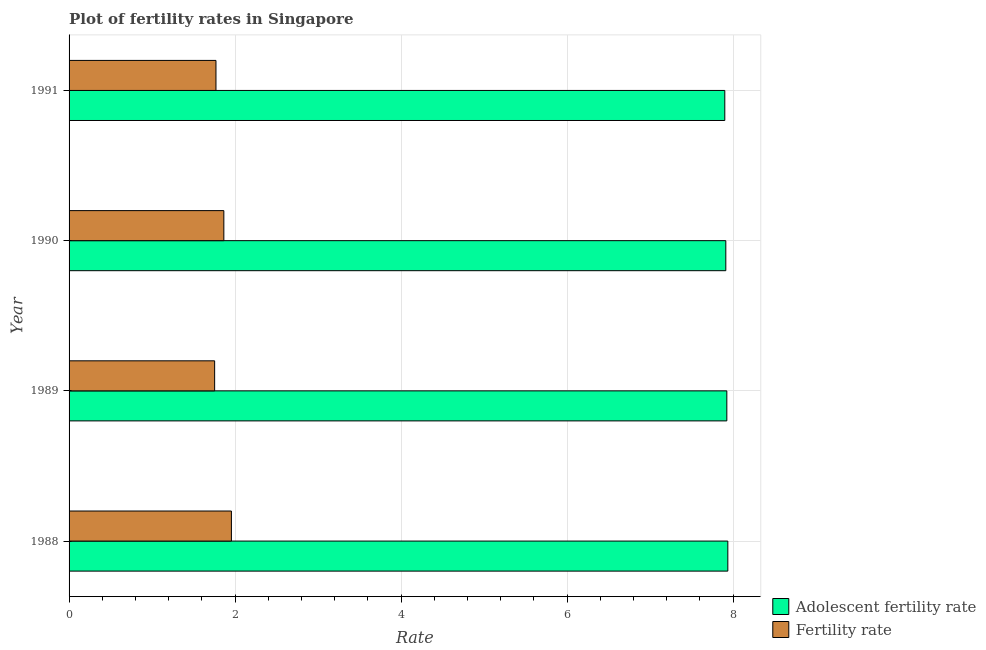Are the number of bars per tick equal to the number of legend labels?
Your answer should be very brief. Yes. Are the number of bars on each tick of the Y-axis equal?
Your response must be concise. Yes. What is the fertility rate in 1991?
Your response must be concise. 1.77. Across all years, what is the maximum adolescent fertility rate?
Make the answer very short. 7.94. Across all years, what is the minimum fertility rate?
Your answer should be compact. 1.75. In which year was the adolescent fertility rate minimum?
Your answer should be very brief. 1991. What is the total fertility rate in the graph?
Provide a short and direct response. 7.35. What is the difference between the adolescent fertility rate in 1989 and that in 1990?
Provide a succinct answer. 0.01. What is the difference between the fertility rate in 1990 and the adolescent fertility rate in 1991?
Offer a very short reply. -6.04. What is the average adolescent fertility rate per year?
Keep it short and to the point. 7.92. In the year 1989, what is the difference between the fertility rate and adolescent fertility rate?
Offer a terse response. -6.17. What is the ratio of the fertility rate in 1990 to that in 1991?
Keep it short and to the point. 1.05. Is the adolescent fertility rate in 1989 less than that in 1991?
Your response must be concise. No. What is the difference between the highest and the second highest adolescent fertility rate?
Provide a short and direct response. 0.01. What does the 2nd bar from the top in 1988 represents?
Provide a short and direct response. Adolescent fertility rate. What does the 1st bar from the bottom in 1991 represents?
Offer a terse response. Adolescent fertility rate. How many bars are there?
Make the answer very short. 8. Are all the bars in the graph horizontal?
Provide a short and direct response. Yes. Are the values on the major ticks of X-axis written in scientific E-notation?
Your response must be concise. No. Where does the legend appear in the graph?
Offer a terse response. Bottom right. How many legend labels are there?
Provide a succinct answer. 2. What is the title of the graph?
Ensure brevity in your answer.  Plot of fertility rates in Singapore. Does "Working capital" appear as one of the legend labels in the graph?
Offer a terse response. No. What is the label or title of the X-axis?
Offer a very short reply. Rate. What is the Rate of Adolescent fertility rate in 1988?
Your answer should be very brief. 7.94. What is the Rate in Fertility rate in 1988?
Your response must be concise. 1.96. What is the Rate in Adolescent fertility rate in 1989?
Offer a very short reply. 7.93. What is the Rate of Fertility rate in 1989?
Provide a succinct answer. 1.75. What is the Rate in Adolescent fertility rate in 1990?
Ensure brevity in your answer.  7.91. What is the Rate of Fertility rate in 1990?
Make the answer very short. 1.86. What is the Rate in Adolescent fertility rate in 1991?
Give a very brief answer. 7.9. What is the Rate in Fertility rate in 1991?
Offer a very short reply. 1.77. Across all years, what is the maximum Rate in Adolescent fertility rate?
Keep it short and to the point. 7.94. Across all years, what is the maximum Rate in Fertility rate?
Your answer should be compact. 1.96. Across all years, what is the minimum Rate of Adolescent fertility rate?
Provide a succinct answer. 7.9. Across all years, what is the minimum Rate of Fertility rate?
Provide a succinct answer. 1.75. What is the total Rate in Adolescent fertility rate in the graph?
Provide a succinct answer. 31.68. What is the total Rate of Fertility rate in the graph?
Offer a terse response. 7.34. What is the difference between the Rate of Adolescent fertility rate in 1988 and that in 1989?
Ensure brevity in your answer.  0.01. What is the difference between the Rate of Fertility rate in 1988 and that in 1989?
Provide a succinct answer. 0.2. What is the difference between the Rate in Adolescent fertility rate in 1988 and that in 1990?
Give a very brief answer. 0.02. What is the difference between the Rate of Fertility rate in 1988 and that in 1990?
Provide a short and direct response. 0.09. What is the difference between the Rate of Adolescent fertility rate in 1988 and that in 1991?
Offer a very short reply. 0.04. What is the difference between the Rate of Fertility rate in 1988 and that in 1991?
Keep it short and to the point. 0.19. What is the difference between the Rate in Adolescent fertility rate in 1989 and that in 1990?
Your answer should be very brief. 0.01. What is the difference between the Rate in Fertility rate in 1989 and that in 1990?
Keep it short and to the point. -0.11. What is the difference between the Rate in Adolescent fertility rate in 1989 and that in 1991?
Ensure brevity in your answer.  0.02. What is the difference between the Rate in Fertility rate in 1989 and that in 1991?
Provide a short and direct response. -0.02. What is the difference between the Rate of Adolescent fertility rate in 1990 and that in 1991?
Make the answer very short. 0.01. What is the difference between the Rate of Fertility rate in 1990 and that in 1991?
Give a very brief answer. 0.1. What is the difference between the Rate in Adolescent fertility rate in 1988 and the Rate in Fertility rate in 1989?
Offer a terse response. 6.18. What is the difference between the Rate of Adolescent fertility rate in 1988 and the Rate of Fertility rate in 1990?
Your response must be concise. 6.07. What is the difference between the Rate of Adolescent fertility rate in 1988 and the Rate of Fertility rate in 1991?
Keep it short and to the point. 6.17. What is the difference between the Rate of Adolescent fertility rate in 1989 and the Rate of Fertility rate in 1990?
Keep it short and to the point. 6.06. What is the difference between the Rate of Adolescent fertility rate in 1989 and the Rate of Fertility rate in 1991?
Give a very brief answer. 6.16. What is the difference between the Rate of Adolescent fertility rate in 1990 and the Rate of Fertility rate in 1991?
Offer a very short reply. 6.14. What is the average Rate in Adolescent fertility rate per year?
Your answer should be compact. 7.92. What is the average Rate in Fertility rate per year?
Your answer should be compact. 1.84. In the year 1988, what is the difference between the Rate in Adolescent fertility rate and Rate in Fertility rate?
Ensure brevity in your answer.  5.98. In the year 1989, what is the difference between the Rate of Adolescent fertility rate and Rate of Fertility rate?
Your answer should be very brief. 6.17. In the year 1990, what is the difference between the Rate in Adolescent fertility rate and Rate in Fertility rate?
Offer a very short reply. 6.05. In the year 1991, what is the difference between the Rate in Adolescent fertility rate and Rate in Fertility rate?
Give a very brief answer. 6.13. What is the ratio of the Rate of Fertility rate in 1988 to that in 1989?
Give a very brief answer. 1.12. What is the ratio of the Rate of Fertility rate in 1988 to that in 1990?
Your answer should be very brief. 1.05. What is the ratio of the Rate in Fertility rate in 1988 to that in 1991?
Give a very brief answer. 1.11. What is the ratio of the Rate of Adolescent fertility rate in 1989 to that in 1990?
Ensure brevity in your answer.  1. What is the ratio of the Rate in Fertility rate in 1989 to that in 1990?
Provide a succinct answer. 0.94. What is the ratio of the Rate of Adolescent fertility rate in 1989 to that in 1991?
Give a very brief answer. 1. What is the ratio of the Rate of Fertility rate in 1989 to that in 1991?
Your response must be concise. 0.99. What is the ratio of the Rate of Adolescent fertility rate in 1990 to that in 1991?
Ensure brevity in your answer.  1. What is the ratio of the Rate of Fertility rate in 1990 to that in 1991?
Offer a terse response. 1.05. What is the difference between the highest and the second highest Rate of Adolescent fertility rate?
Ensure brevity in your answer.  0.01. What is the difference between the highest and the second highest Rate of Fertility rate?
Offer a terse response. 0.09. What is the difference between the highest and the lowest Rate in Adolescent fertility rate?
Make the answer very short. 0.04. What is the difference between the highest and the lowest Rate in Fertility rate?
Offer a very short reply. 0.2. 